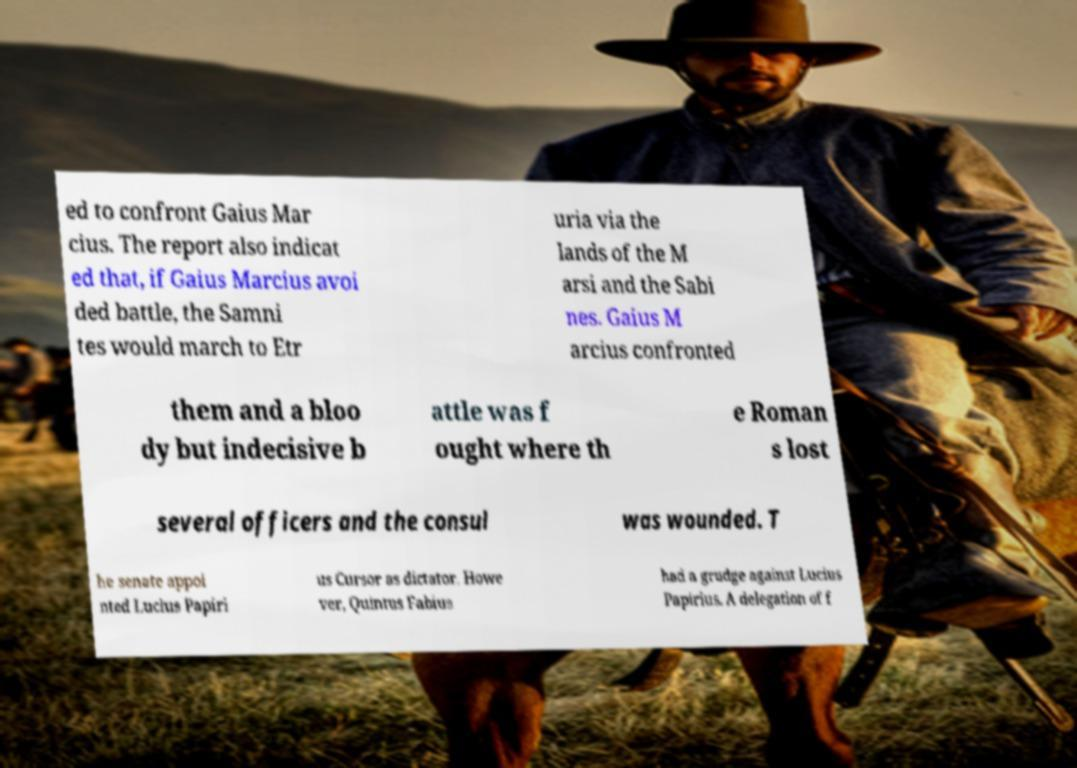Can you read and provide the text displayed in the image?This photo seems to have some interesting text. Can you extract and type it out for me? ed to confront Gaius Mar cius. The report also indicat ed that, if Gaius Marcius avoi ded battle, the Samni tes would march to Etr uria via the lands of the M arsi and the Sabi nes. Gaius M arcius confronted them and a bloo dy but indecisive b attle was f ought where th e Roman s lost several officers and the consul was wounded. T he senate appoi nted Lucius Papiri us Cursor as dictator. Howe ver, Quintus Fabius had a grudge against Lucius Papirius. A delegation of f 